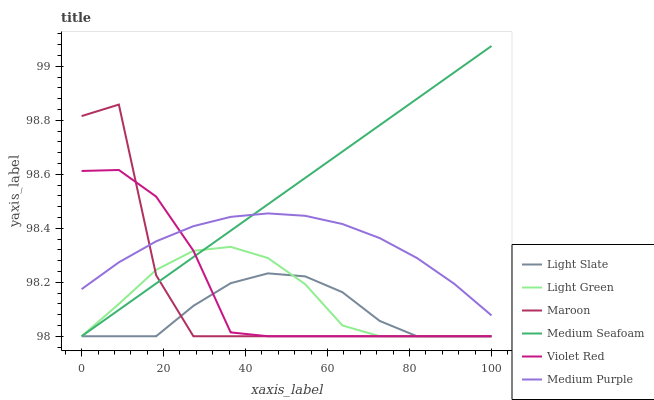Does Maroon have the minimum area under the curve?
Answer yes or no. No. Does Maroon have the maximum area under the curve?
Answer yes or no. No. Is Light Slate the smoothest?
Answer yes or no. No. Is Light Slate the roughest?
Answer yes or no. No. Does Medium Purple have the lowest value?
Answer yes or no. No. Does Maroon have the highest value?
Answer yes or no. No. Is Light Slate less than Medium Purple?
Answer yes or no. Yes. Is Medium Purple greater than Light Slate?
Answer yes or no. Yes. Does Light Slate intersect Medium Purple?
Answer yes or no. No. 